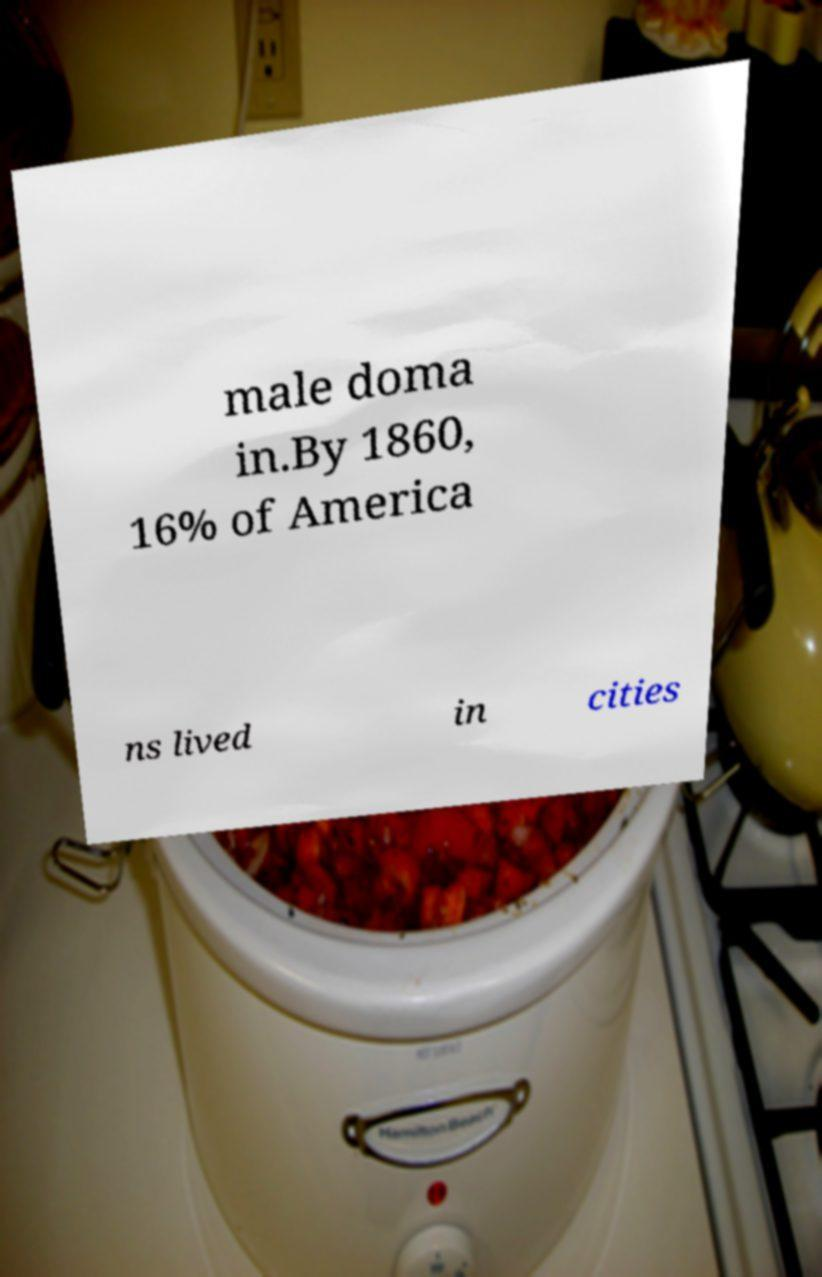I need the written content from this picture converted into text. Can you do that? male doma in.By 1860, 16% of America ns lived in cities 